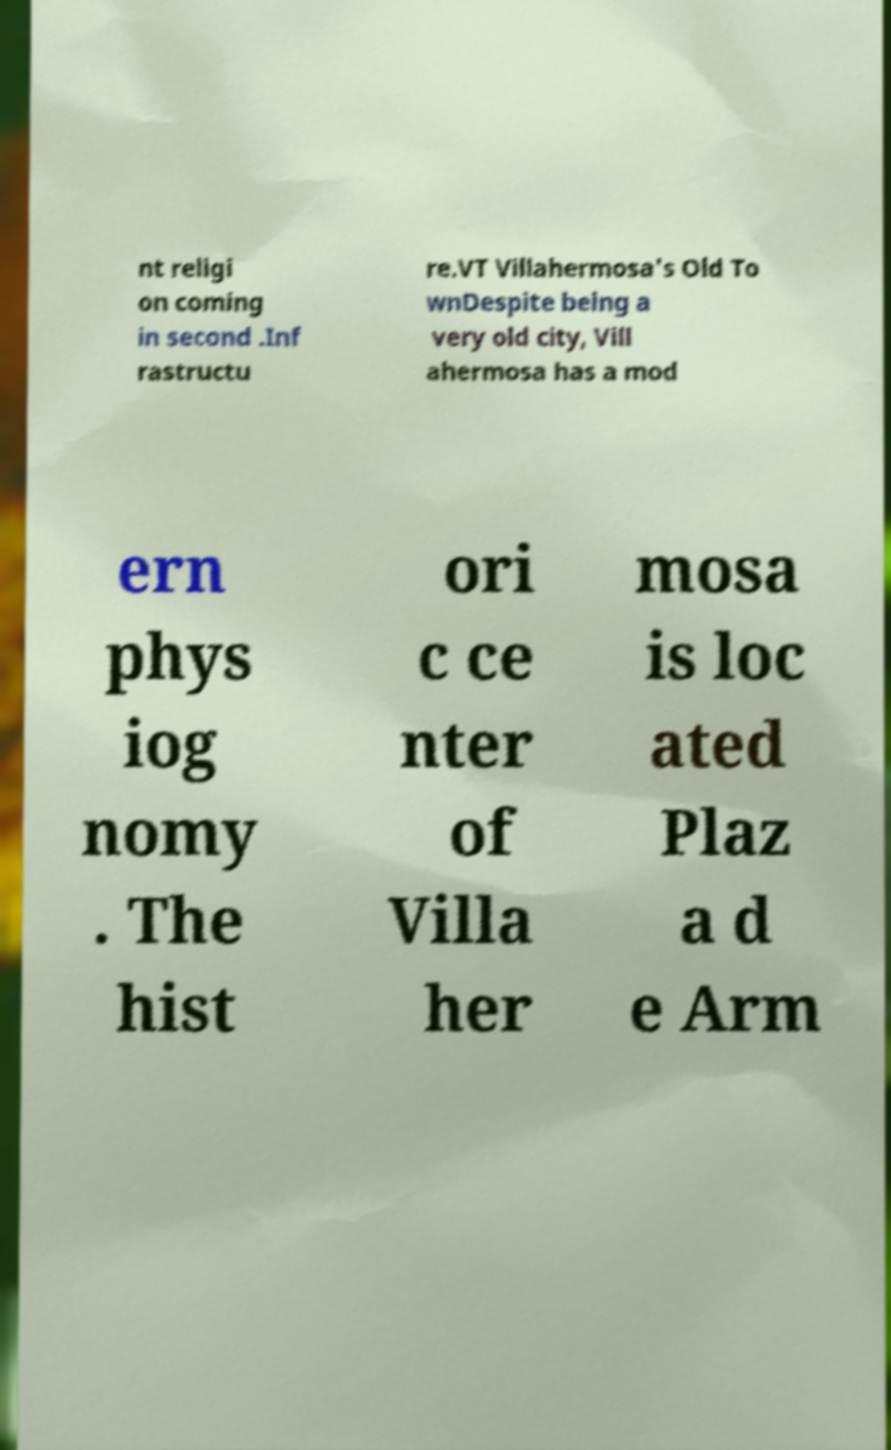What messages or text are displayed in this image? I need them in a readable, typed format. nt religi on coming in second .Inf rastructu re.VT Villahermosa's Old To wnDespite being a very old city, Vill ahermosa has a mod ern phys iog nomy . The hist ori c ce nter of Villa her mosa is loc ated Plaz a d e Arm 